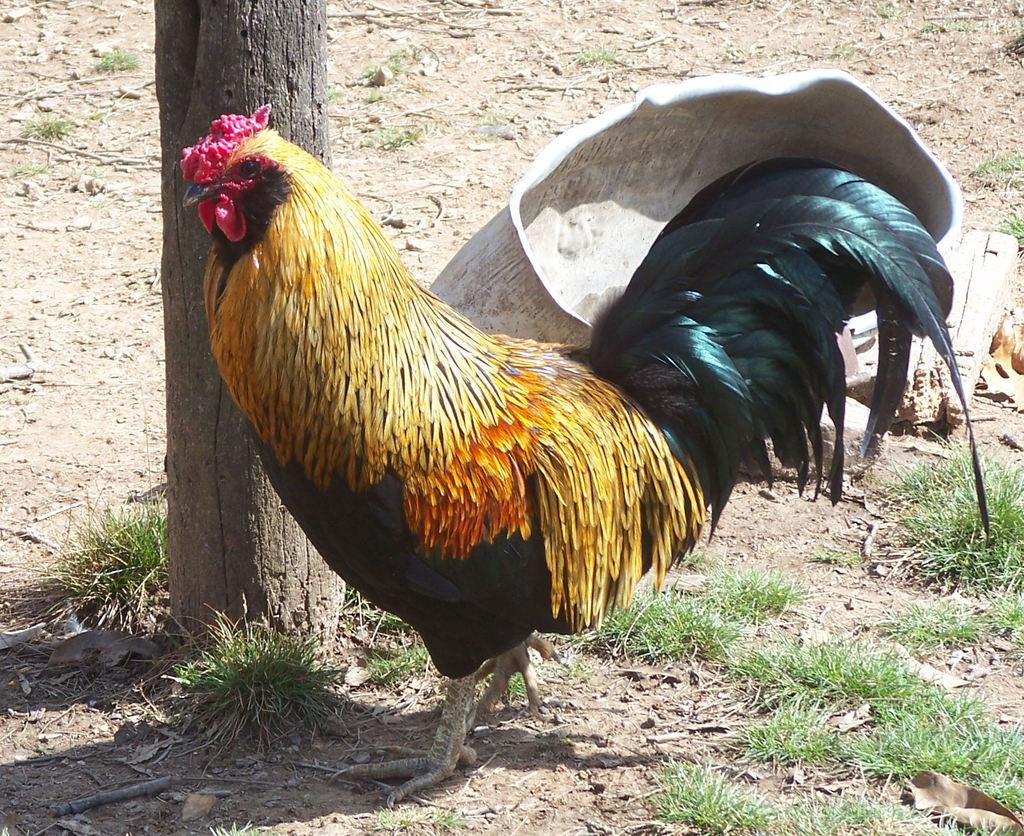What type of animal is in the image? There is a hen in the image. What is the hen's position in relation to the ground? The hen is standing on the ground. What is the hen standing beside? The hen is beside a tree trunk. What is located behind the hen? There is an object behind the hen. What type of vegetation is around the hen? There is grass around the hen. What type of produce is the hen using to play the drum in the image? There is no produce or drum present in the image; it features a hen standing beside a tree trunk. 